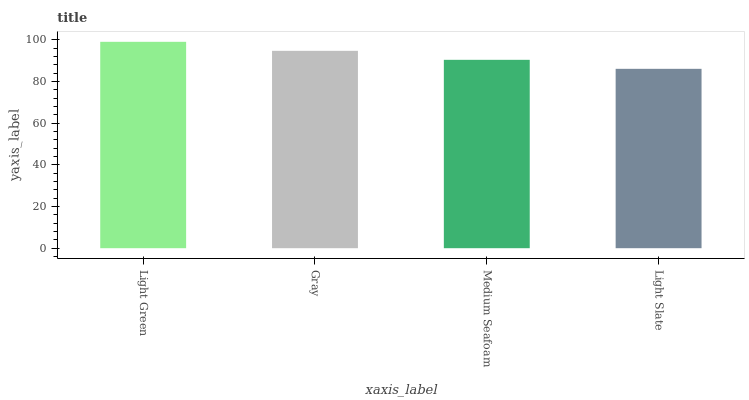Is Light Slate the minimum?
Answer yes or no. Yes. Is Light Green the maximum?
Answer yes or no. Yes. Is Gray the minimum?
Answer yes or no. No. Is Gray the maximum?
Answer yes or no. No. Is Light Green greater than Gray?
Answer yes or no. Yes. Is Gray less than Light Green?
Answer yes or no. Yes. Is Gray greater than Light Green?
Answer yes or no. No. Is Light Green less than Gray?
Answer yes or no. No. Is Gray the high median?
Answer yes or no. Yes. Is Medium Seafoam the low median?
Answer yes or no. Yes. Is Medium Seafoam the high median?
Answer yes or no. No. Is Gray the low median?
Answer yes or no. No. 